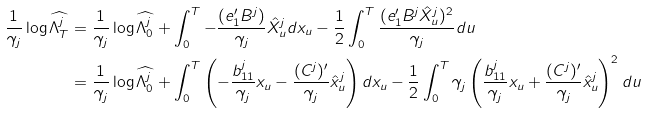Convert formula to latex. <formula><loc_0><loc_0><loc_500><loc_500>\frac { 1 } { \gamma _ { j } } \log \widehat { \Lambda ^ { j } _ { T } } & = \frac { 1 } { \gamma _ { j } } \log \widehat { \Lambda ^ { j } _ { 0 } } + \int _ { 0 } ^ { T } - \frac { ( e _ { 1 } ^ { \prime } B ^ { j } ) } { \gamma _ { j } } \hat { X } ^ { j } _ { u } d x _ { u } - \frac { 1 } { 2 } \int _ { 0 } ^ { T } \frac { ( e _ { 1 } ^ { \prime } B ^ { j } \hat { X } ^ { j } _ { u } ) ^ { 2 } } { \gamma _ { j } } d u \\ & = \frac { 1 } { \gamma _ { j } } \log \widehat { \Lambda ^ { j } _ { 0 } } + \int _ { 0 } ^ { T } \left ( - \frac { b _ { 1 1 } ^ { j } } { \gamma _ { j } } x _ { u } - \frac { ( C ^ { j } ) ^ { \prime } } { \gamma _ { j } } \hat { x } ^ { j } _ { u } \right ) d x _ { u } - \frac { 1 } { 2 } \int _ { 0 } ^ { T } \gamma _ { j } \left ( \frac { b _ { 1 1 } ^ { j } } { \gamma _ { j } } x _ { u } + \frac { ( C ^ { j } ) ^ { \prime } } { \gamma _ { j } } \hat { x } ^ { j } _ { u } \right ) ^ { 2 } d u</formula> 